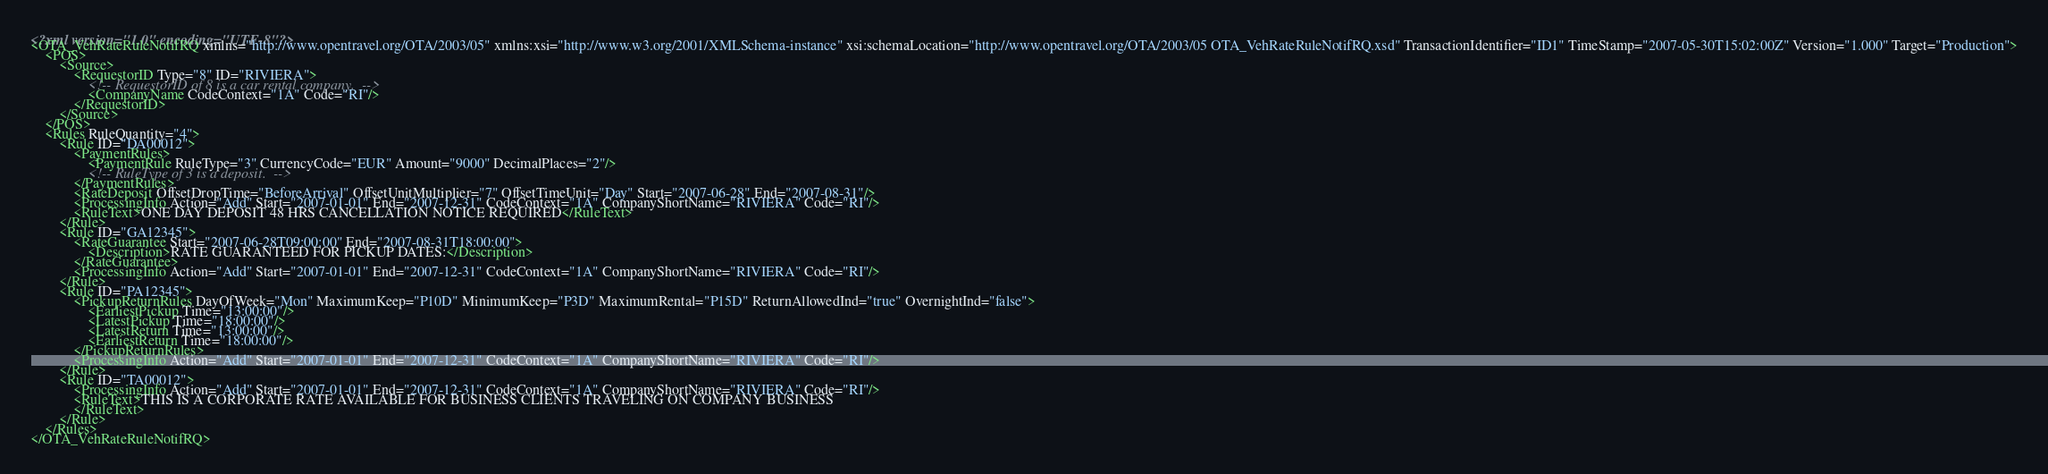Convert code to text. <code><loc_0><loc_0><loc_500><loc_500><_XML_><?xml version="1.0" encoding="UTF-8"?><OTA_VehRateRuleNotifRQ xmlns="http://www.opentravel.org/OTA/2003/05" xmlns:xsi="http://www.w3.org/2001/XMLSchema-instance" xsi:schemaLocation="http://www.opentravel.org/OTA/2003/05 OTA_VehRateRuleNotifRQ.xsd" TransactionIdentifier="ID1" TimeStamp="2007-05-30T15:02:00Z" Version="1.000" Target="Production">	<POS>		<Source>			<RequestorID Type="8" ID="RIVIERA">				<!-- RequestorID of 8 is a car rental company.  -->				<CompanyName CodeContext="1A" Code="RI"/>			</RequestorID>		</Source>	</POS>	<Rules RuleQuantity="4">		<Rule ID="DA00012">			<PaymentRules>				<PaymentRule RuleType="3" CurrencyCode="EUR" Amount="9000" DecimalPlaces="2"/>				<!-- RuleType of 3 is a deposit.  -->			</PaymentRules>			<RateDeposit OffsetDropTime="BeforeArrival" OffsetUnitMultiplier="7" OffsetTimeUnit="Day" Start="2007-06-28" End="2007-08-31"/>			<ProcessingInfo Action="Add" Start="2007-01-01" End="2007-12-31" CodeContext="1A" CompanyShortName="RIVIERA" Code="RI"/>			<RuleText>ONE DAY DEPOSIT 48 HRS CANCELLATION NOTICE REQUIRED</RuleText>		</Rule>		<Rule ID="GA12345">			<RateGuarantee Start="2007-06-28T09:00:00" End="2007-08-31T18:00:00">				<Description>RATE GUARANTEED FOR PICKUP DATES:</Description>			</RateGuarantee>			<ProcessingInfo Action="Add" Start="2007-01-01" End="2007-12-31" CodeContext="1A" CompanyShortName="RIVIERA" Code="RI"/>		</Rule>		<Rule ID="PA12345">			<PickupReturnRules DayOfWeek="Mon" MaximumKeep="P10D" MinimumKeep="P3D" MaximumRental="P15D" ReturnAllowedInd="true" OvernightInd="false">				<EarliestPickup Time="13:00:00"/>				<LatestPickup Time="18:00:00"/>				<LatestReturn Time="13:00:00"/>				<EarliestReturn Time="18:00:00"/>			</PickupReturnRules>			<ProcessingInfo Action="Add" Start="2007-01-01" End="2007-12-31" CodeContext="1A" CompanyShortName="RIVIERA" Code="RI"/>		</Rule>		<Rule ID="TA00012">			<ProcessingInfo Action="Add" Start="2007-01-01" End="2007-12-31" CodeContext="1A" CompanyShortName="RIVIERA" Code="RI"/>			<RuleText>THIS IS A CORPORATE RATE AVAILABLE FOR BUSINESS CLIENTS TRAVELING ON COMPANY BUSINESS 			</RuleText>		</Rule>	</Rules></OTA_VehRateRuleNotifRQ></code> 